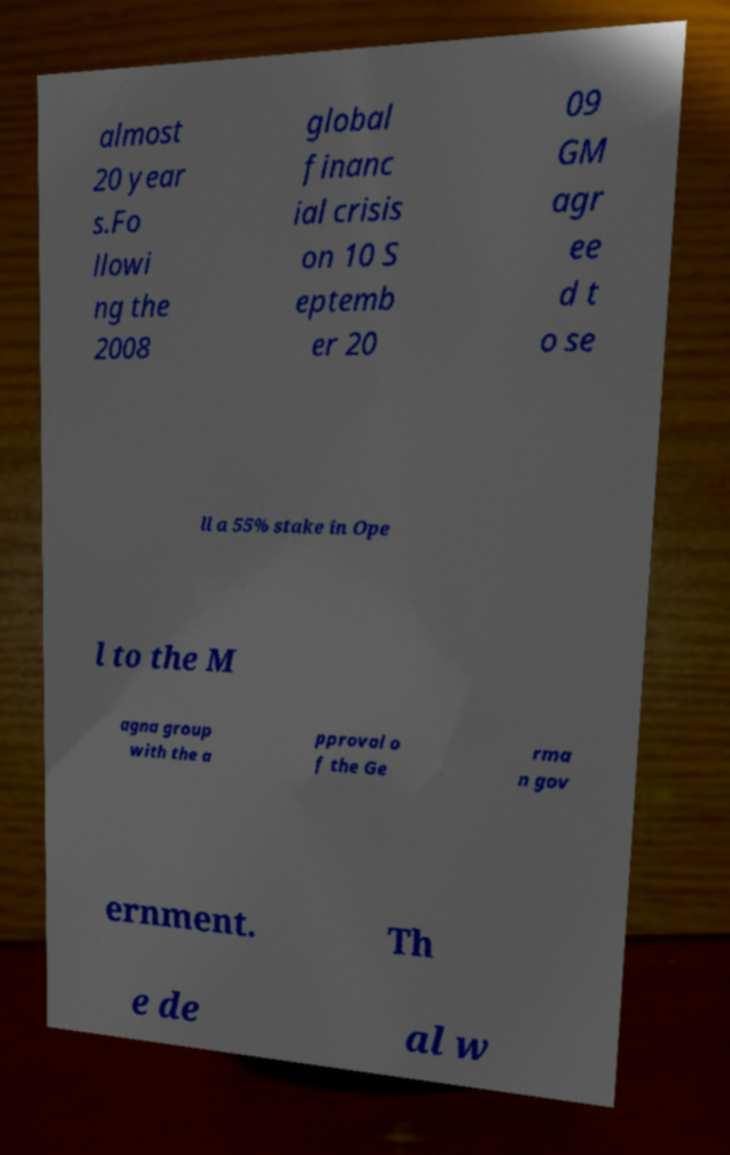There's text embedded in this image that I need extracted. Can you transcribe it verbatim? almost 20 year s.Fo llowi ng the 2008 global financ ial crisis on 10 S eptemb er 20 09 GM agr ee d t o se ll a 55% stake in Ope l to the M agna group with the a pproval o f the Ge rma n gov ernment. Th e de al w 